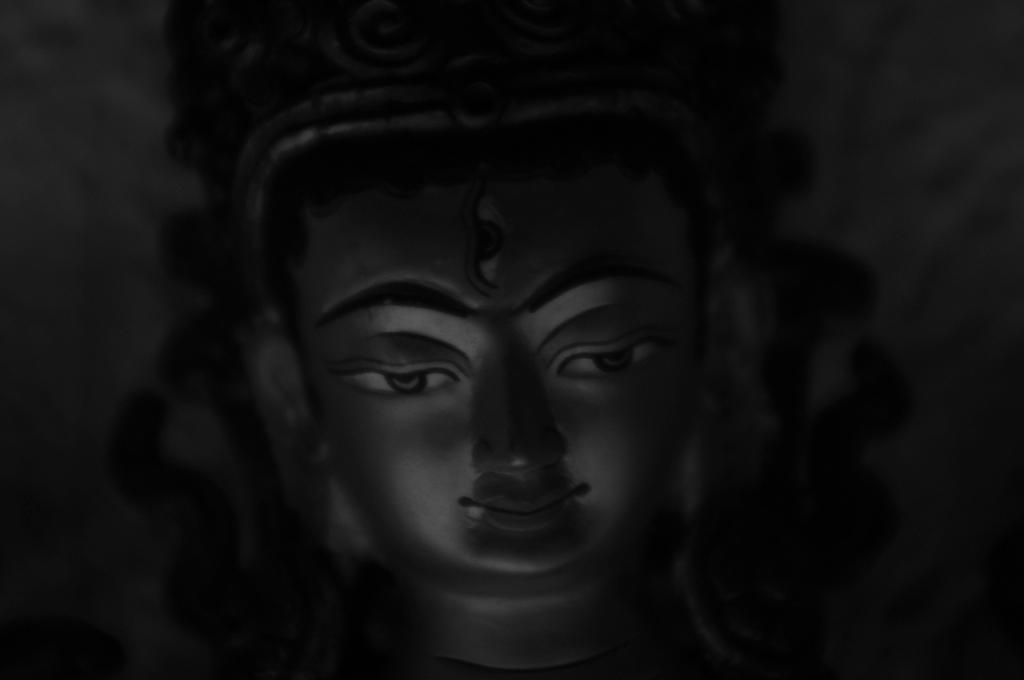What is the color scheme of the image? The image is black and white. What is the main subject in the middle of the image? There is an idol in the middle of the image. What color is the background of the image? The background of the image is black. What type of meat is being prepared in the image? There is no meat present in the image; it is a black and white image featuring an idol with a black background. 